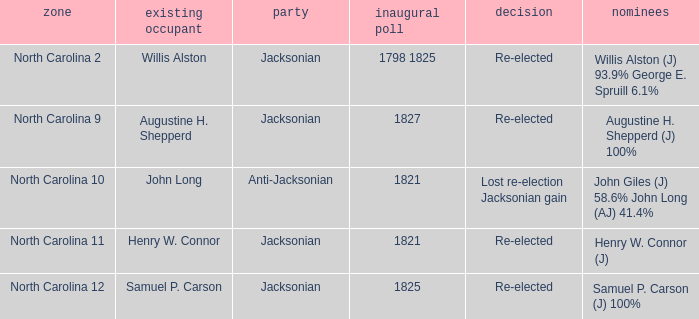Name the total number of party for willis alston 1.0. 